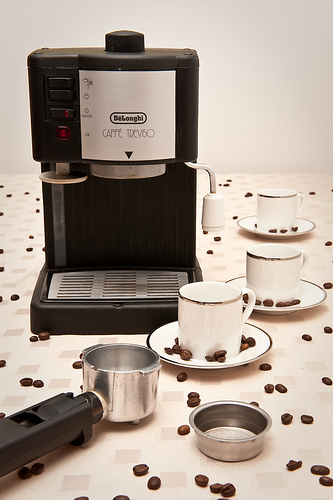<image>
Is the cup above the saucer? No. The cup is not positioned above the saucer. The vertical arrangement shows a different relationship. 